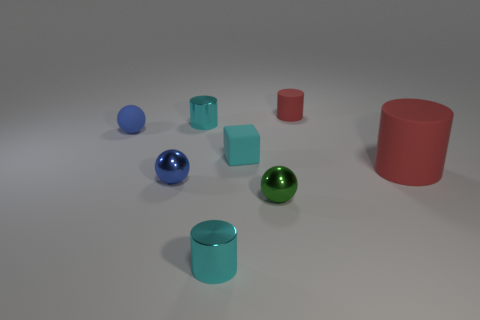What is the shape of the tiny thing that is the same color as the big rubber cylinder?
Keep it short and to the point. Cylinder. Are there any large red shiny things?
Give a very brief answer. No. What is the size of the blue object that is made of the same material as the small cyan cube?
Give a very brief answer. Small. The red thing behind the tiny shiny cylinder behind the cylinder that is in front of the tiny green metallic object is what shape?
Your answer should be compact. Cylinder. Is the number of tiny blue rubber things right of the small rubber sphere the same as the number of small cyan metallic things?
Make the answer very short. No. There is a metallic sphere that is the same color as the matte sphere; what size is it?
Offer a very short reply. Small. Does the small green metal object have the same shape as the small blue rubber thing?
Provide a succinct answer. Yes. How many objects are cylinders in front of the small red thing or small brown blocks?
Offer a very short reply. 3. Is the number of cyan metal cylinders that are to the right of the cyan matte thing the same as the number of tiny matte balls in front of the small red cylinder?
Offer a terse response. No. How many other objects are the same shape as the blue shiny thing?
Provide a short and direct response. 2. 